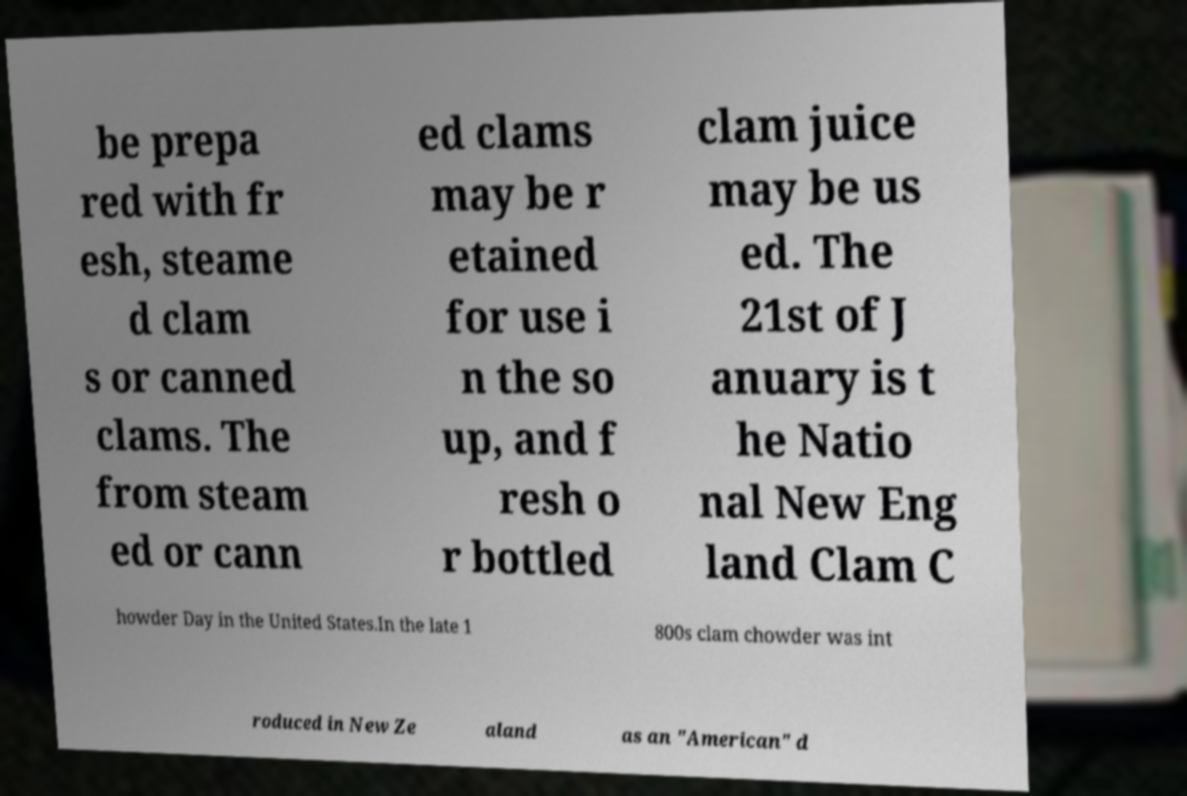For documentation purposes, I need the text within this image transcribed. Could you provide that? be prepa red with fr esh, steame d clam s or canned clams. The from steam ed or cann ed clams may be r etained for use i n the so up, and f resh o r bottled clam juice may be us ed. The 21st of J anuary is t he Natio nal New Eng land Clam C howder Day in the United States.In the late 1 800s clam chowder was int roduced in New Ze aland as an "American" d 